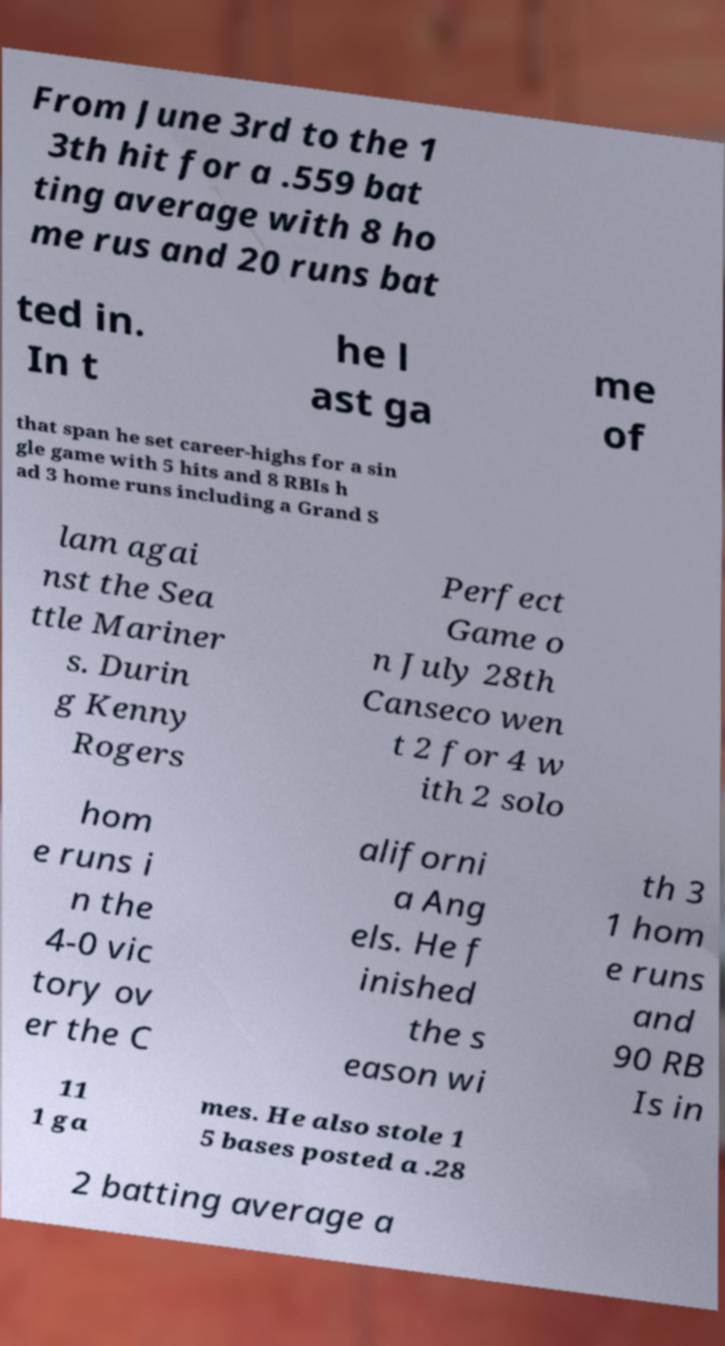Could you extract and type out the text from this image? From June 3rd to the 1 3th hit for a .559 bat ting average with 8 ho me rus and 20 runs bat ted in. In t he l ast ga me of that span he set career-highs for a sin gle game with 5 hits and 8 RBIs h ad 3 home runs including a Grand S lam agai nst the Sea ttle Mariner s. Durin g Kenny Rogers Perfect Game o n July 28th Canseco wen t 2 for 4 w ith 2 solo hom e runs i n the 4-0 vic tory ov er the C aliforni a Ang els. He f inished the s eason wi th 3 1 hom e runs and 90 RB Is in 11 1 ga mes. He also stole 1 5 bases posted a .28 2 batting average a 